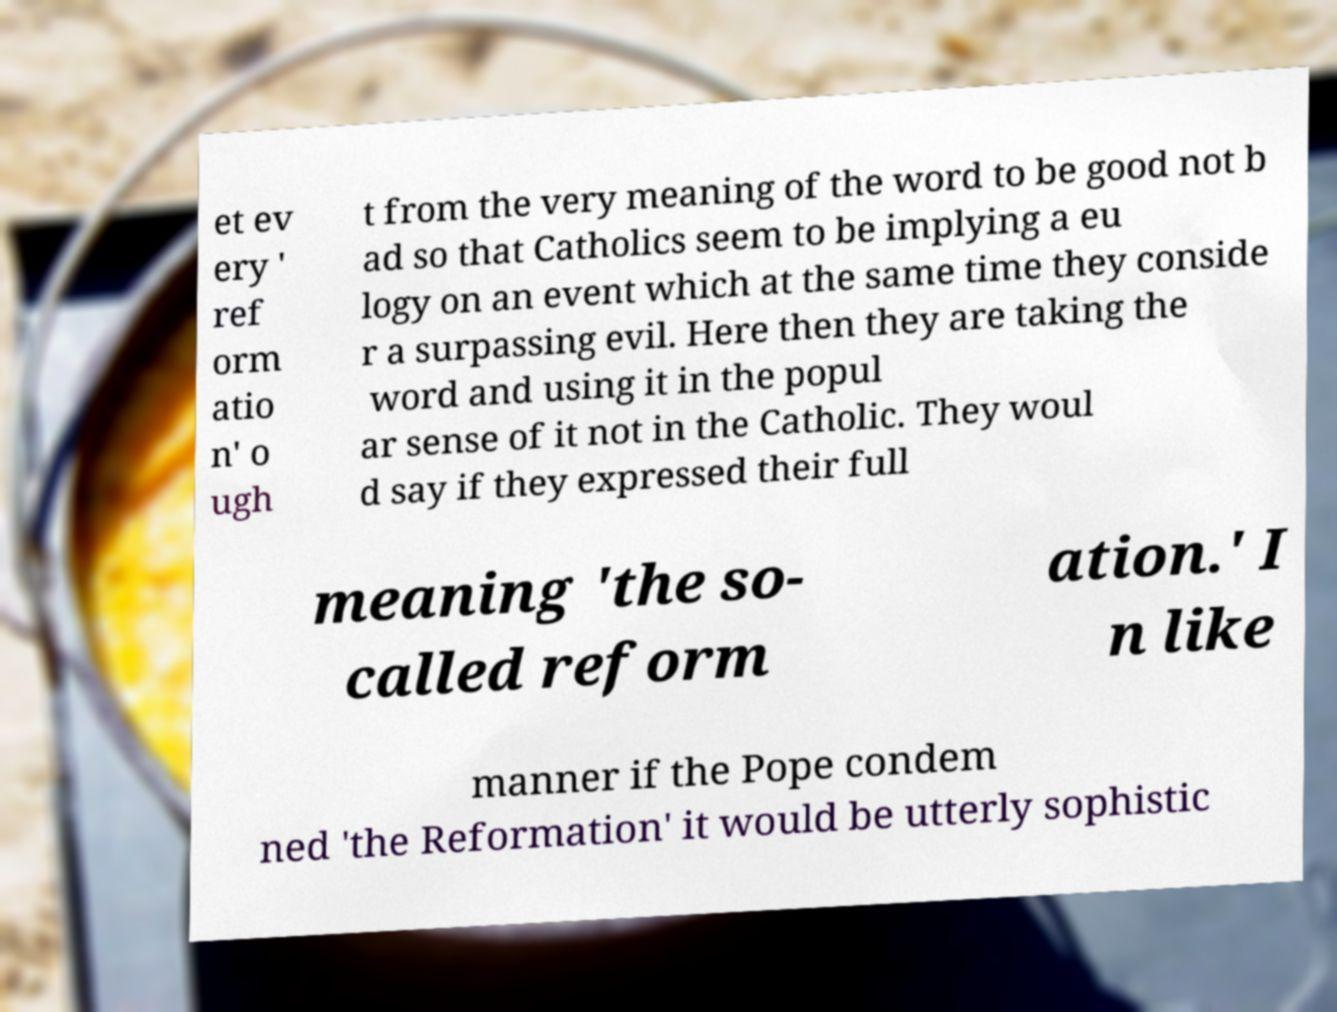Can you accurately transcribe the text from the provided image for me? et ev ery ' ref orm atio n' o ugh t from the very meaning of the word to be good not b ad so that Catholics seem to be implying a eu logy on an event which at the same time they conside r a surpassing evil. Here then they are taking the word and using it in the popul ar sense of it not in the Catholic. They woul d say if they expressed their full meaning 'the so- called reform ation.' I n like manner if the Pope condem ned 'the Reformation' it would be utterly sophistic 